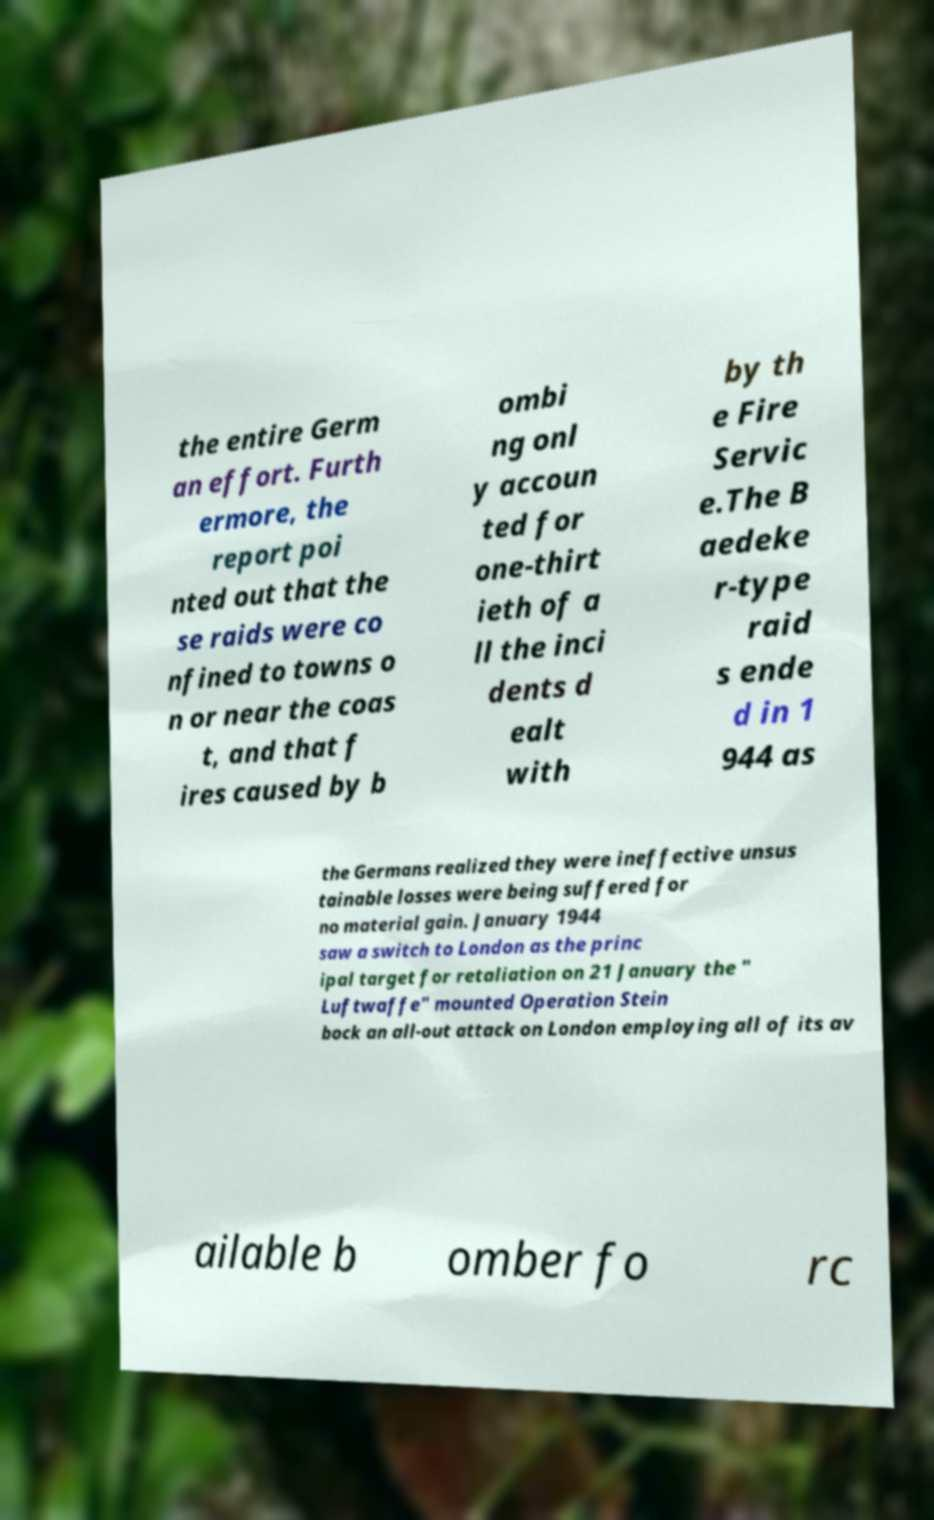I need the written content from this picture converted into text. Can you do that? the entire Germ an effort. Furth ermore, the report poi nted out that the se raids were co nfined to towns o n or near the coas t, and that f ires caused by b ombi ng onl y accoun ted for one-thirt ieth of a ll the inci dents d ealt with by th e Fire Servic e.The B aedeke r-type raid s ende d in 1 944 as the Germans realized they were ineffective unsus tainable losses were being suffered for no material gain. January 1944 saw a switch to London as the princ ipal target for retaliation on 21 January the " Luftwaffe" mounted Operation Stein bock an all-out attack on London employing all of its av ailable b omber fo rc 